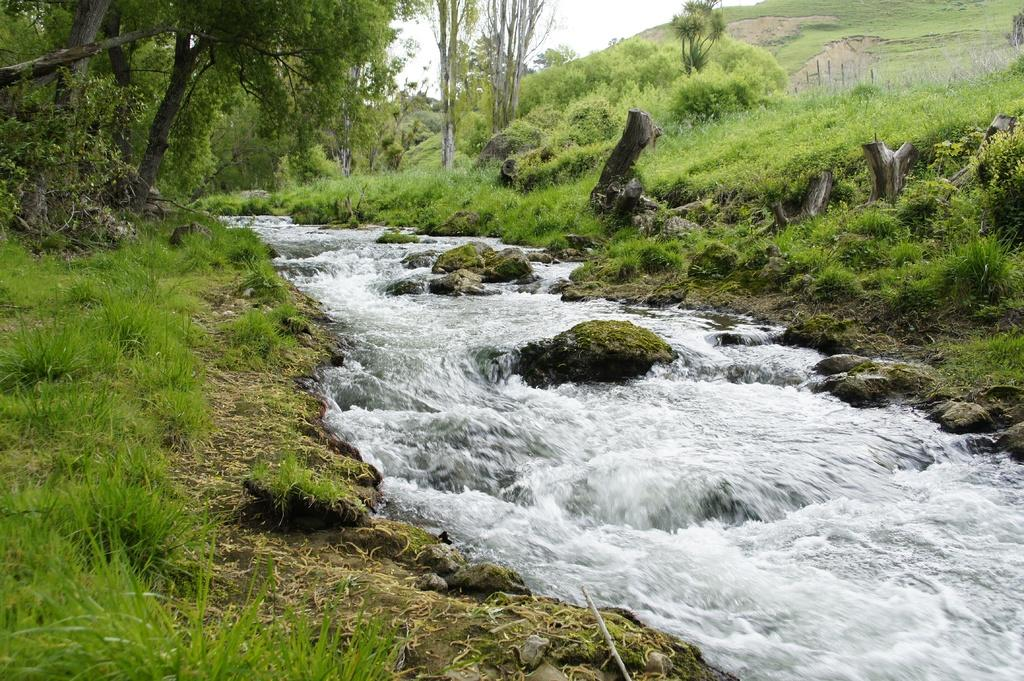What is the main feature in the middle of the image? There is a river in the middle of the image. What type of vegetation is present on either side of the river? There is grass on either side of the river. What can be seen in the background of the image? There are trees in the background of the image. What is visible at the bottom of the image? There are stones visible at the bottom of the image. How many goldfish can be seen swimming in the river in the image? There are no goldfish visible in the image; it only shows a river, grass, trees, and stones. What type of elbow is present in the image? There is no elbow present in the image. 